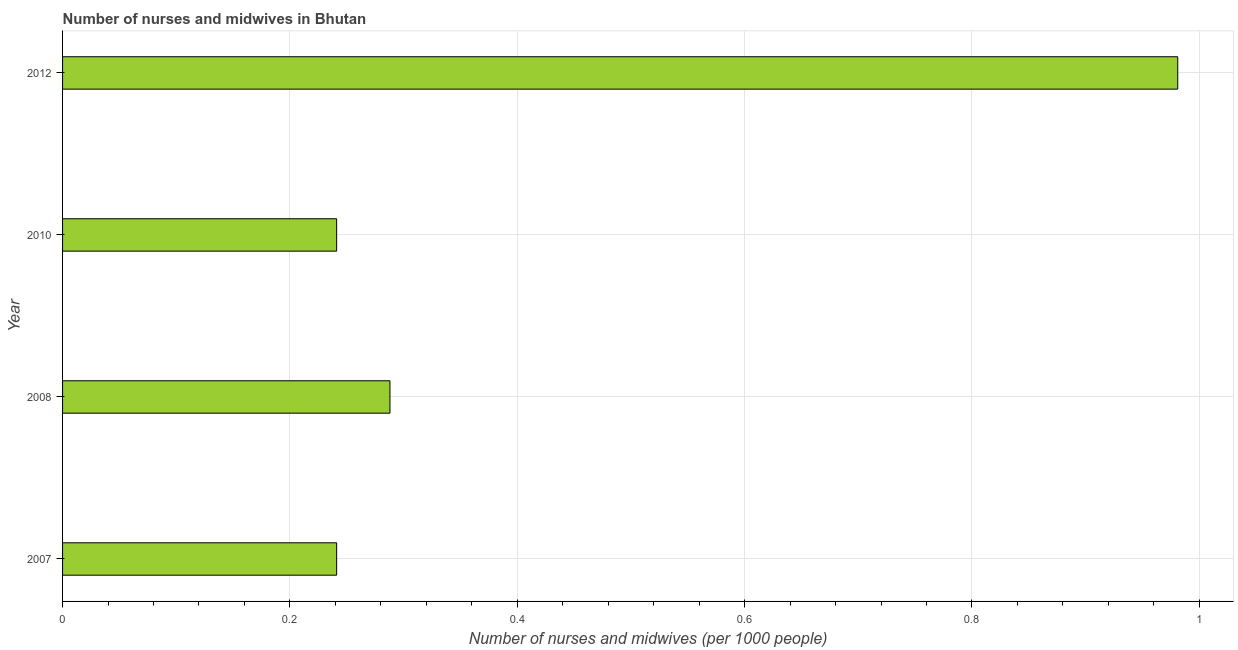Does the graph contain any zero values?
Offer a very short reply. No. What is the title of the graph?
Your response must be concise. Number of nurses and midwives in Bhutan. What is the label or title of the X-axis?
Give a very brief answer. Number of nurses and midwives (per 1000 people). What is the label or title of the Y-axis?
Make the answer very short. Year. What is the number of nurses and midwives in 2008?
Offer a very short reply. 0.29. Across all years, what is the minimum number of nurses and midwives?
Give a very brief answer. 0.24. In which year was the number of nurses and midwives minimum?
Ensure brevity in your answer.  2007. What is the sum of the number of nurses and midwives?
Your answer should be very brief. 1.75. What is the difference between the number of nurses and midwives in 2008 and 2012?
Your response must be concise. -0.69. What is the average number of nurses and midwives per year?
Ensure brevity in your answer.  0.44. What is the median number of nurses and midwives?
Make the answer very short. 0.26. In how many years, is the number of nurses and midwives greater than 0.96 ?
Keep it short and to the point. 1. Is the number of nurses and midwives in 2007 less than that in 2008?
Provide a short and direct response. Yes. What is the difference between the highest and the second highest number of nurses and midwives?
Your answer should be very brief. 0.69. What is the difference between the highest and the lowest number of nurses and midwives?
Make the answer very short. 0.74. In how many years, is the number of nurses and midwives greater than the average number of nurses and midwives taken over all years?
Offer a very short reply. 1. How many years are there in the graph?
Make the answer very short. 4. Are the values on the major ticks of X-axis written in scientific E-notation?
Ensure brevity in your answer.  No. What is the Number of nurses and midwives (per 1000 people) in 2007?
Your response must be concise. 0.24. What is the Number of nurses and midwives (per 1000 people) in 2008?
Your response must be concise. 0.29. What is the Number of nurses and midwives (per 1000 people) in 2010?
Your response must be concise. 0.24. What is the difference between the Number of nurses and midwives (per 1000 people) in 2007 and 2008?
Your response must be concise. -0.05. What is the difference between the Number of nurses and midwives (per 1000 people) in 2007 and 2010?
Ensure brevity in your answer.  0. What is the difference between the Number of nurses and midwives (per 1000 people) in 2007 and 2012?
Your answer should be very brief. -0.74. What is the difference between the Number of nurses and midwives (per 1000 people) in 2008 and 2010?
Offer a terse response. 0.05. What is the difference between the Number of nurses and midwives (per 1000 people) in 2008 and 2012?
Your answer should be compact. -0.69. What is the difference between the Number of nurses and midwives (per 1000 people) in 2010 and 2012?
Offer a very short reply. -0.74. What is the ratio of the Number of nurses and midwives (per 1000 people) in 2007 to that in 2008?
Your response must be concise. 0.84. What is the ratio of the Number of nurses and midwives (per 1000 people) in 2007 to that in 2010?
Provide a succinct answer. 1. What is the ratio of the Number of nurses and midwives (per 1000 people) in 2007 to that in 2012?
Provide a succinct answer. 0.25. What is the ratio of the Number of nurses and midwives (per 1000 people) in 2008 to that in 2010?
Your answer should be very brief. 1.2. What is the ratio of the Number of nurses and midwives (per 1000 people) in 2008 to that in 2012?
Provide a succinct answer. 0.29. What is the ratio of the Number of nurses and midwives (per 1000 people) in 2010 to that in 2012?
Offer a very short reply. 0.25. 